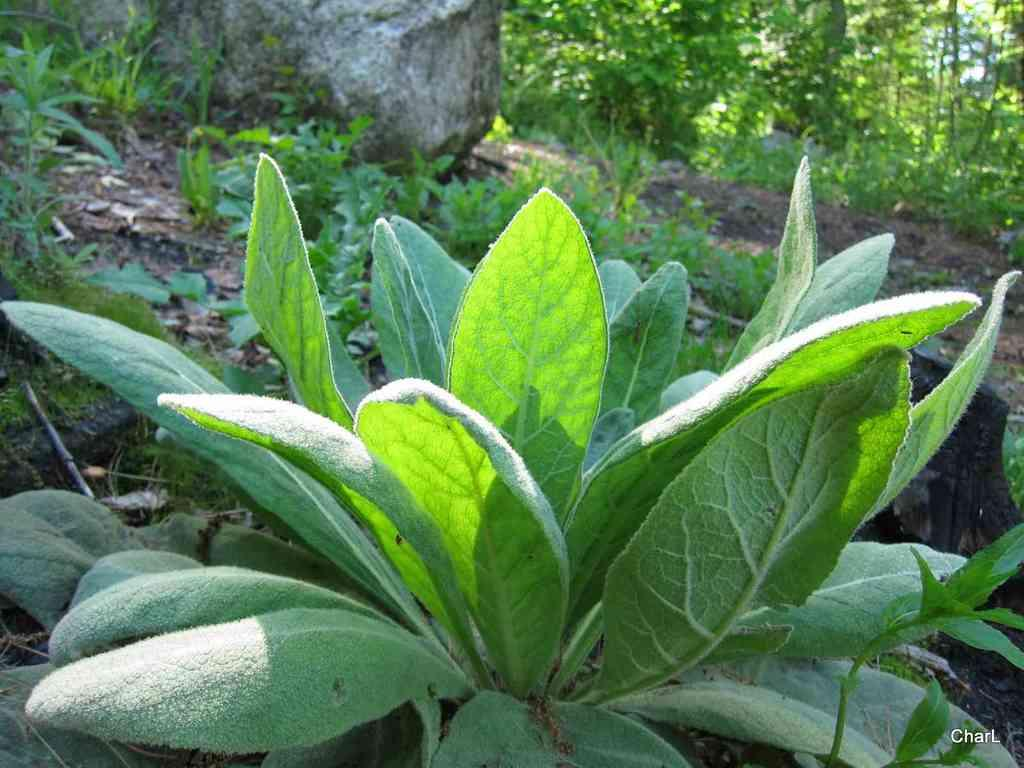What type of vegetation can be seen at the bottom of the image? There are plants in the bottom of the image. What can be seen on the top right side of the image? There are trees on the top right side of the image. What is located on the top left side of the image? There is a rock on the top left side of the image. What story is being told by the rock on the top left side of the image? There is no story being told by the rock in the image; it is simply a rock. How many sides does the rock have in the image? The number of sides the rock has cannot be determined from the image alone. 